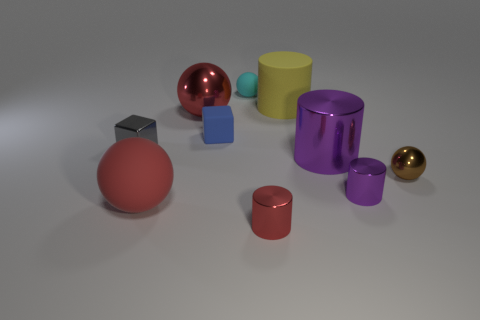There is another metal ball that is the same size as the cyan ball; what is its color?
Your answer should be compact. Brown. How many large things are either gray rubber blocks or gray shiny objects?
Your answer should be compact. 0. Are there more small blue cubes to the right of the blue cube than small cylinders left of the small purple metal cylinder?
Offer a terse response. No. The metallic cylinder that is the same color as the large rubber sphere is what size?
Ensure brevity in your answer.  Small. What number of other things are the same size as the blue matte block?
Offer a terse response. 5. Is the material of the red thing that is behind the brown object the same as the gray object?
Make the answer very short. Yes. What number of other objects are the same color as the large rubber ball?
Your response must be concise. 2. What number of other objects are there of the same shape as the small purple thing?
Provide a short and direct response. 3. There is a big shiny object that is on the right side of the tiny red thing; does it have the same shape as the red shiny object in front of the tiny blue object?
Offer a terse response. Yes. Are there an equal number of big red matte objects to the right of the tiny purple shiny cylinder and big red things in front of the small shiny ball?
Give a very brief answer. No. 